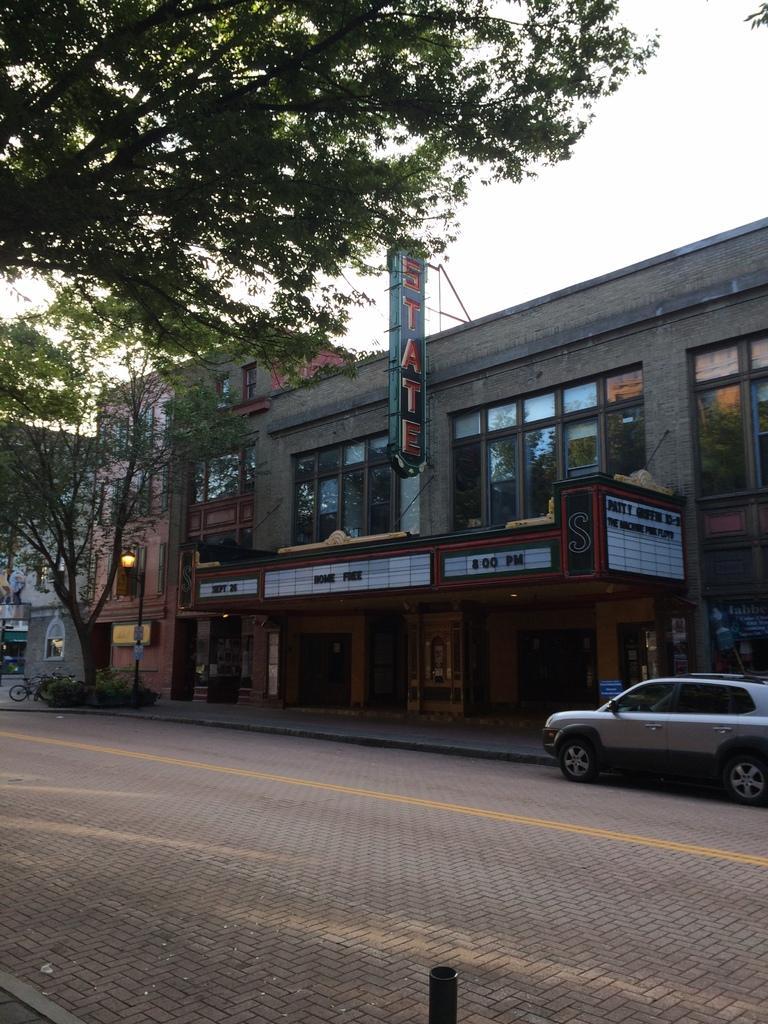Can you describe this image briefly? In this image there are buildings and trees. There are boards. On the left we can see a bicycle. On the right there is a car. There is a pole. In the background there is sky. 